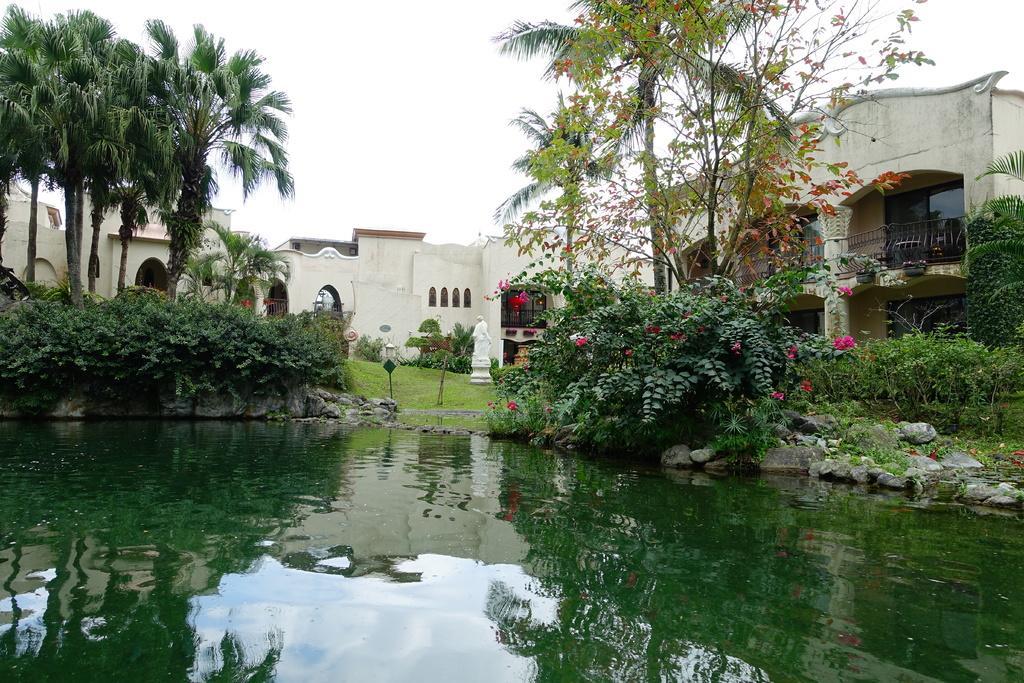Could you give a brief overview of what you see in this image? In this image, we can see trees, plants, buildings, poles, railings and a statue. At the bottom, there is water and we can see some rocks. 